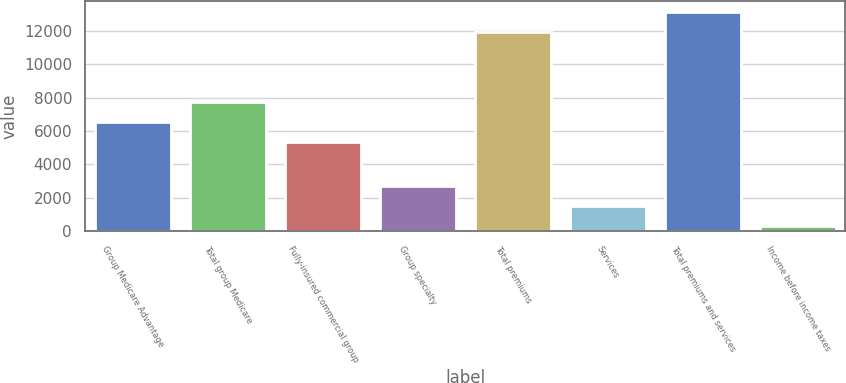Convert chart to OTSL. <chart><loc_0><loc_0><loc_500><loc_500><bar_chart><fcel>Group Medicare Advantage<fcel>Total group Medicare<fcel>Fully-insured commercial group<fcel>Group specialty<fcel>Total premiums<fcel>Services<fcel>Total premiums and services<fcel>Income before income taxes<nl><fcel>6537.3<fcel>7735.6<fcel>5339<fcel>2710.6<fcel>11935<fcel>1512.3<fcel>13133.3<fcel>314<nl></chart> 